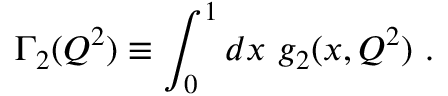<formula> <loc_0><loc_0><loc_500><loc_500>\Gamma _ { 2 } ( Q ^ { 2 } ) \equiv \int _ { 0 } ^ { 1 } d x g _ { 2 } ( x , Q ^ { 2 } ) .</formula> 